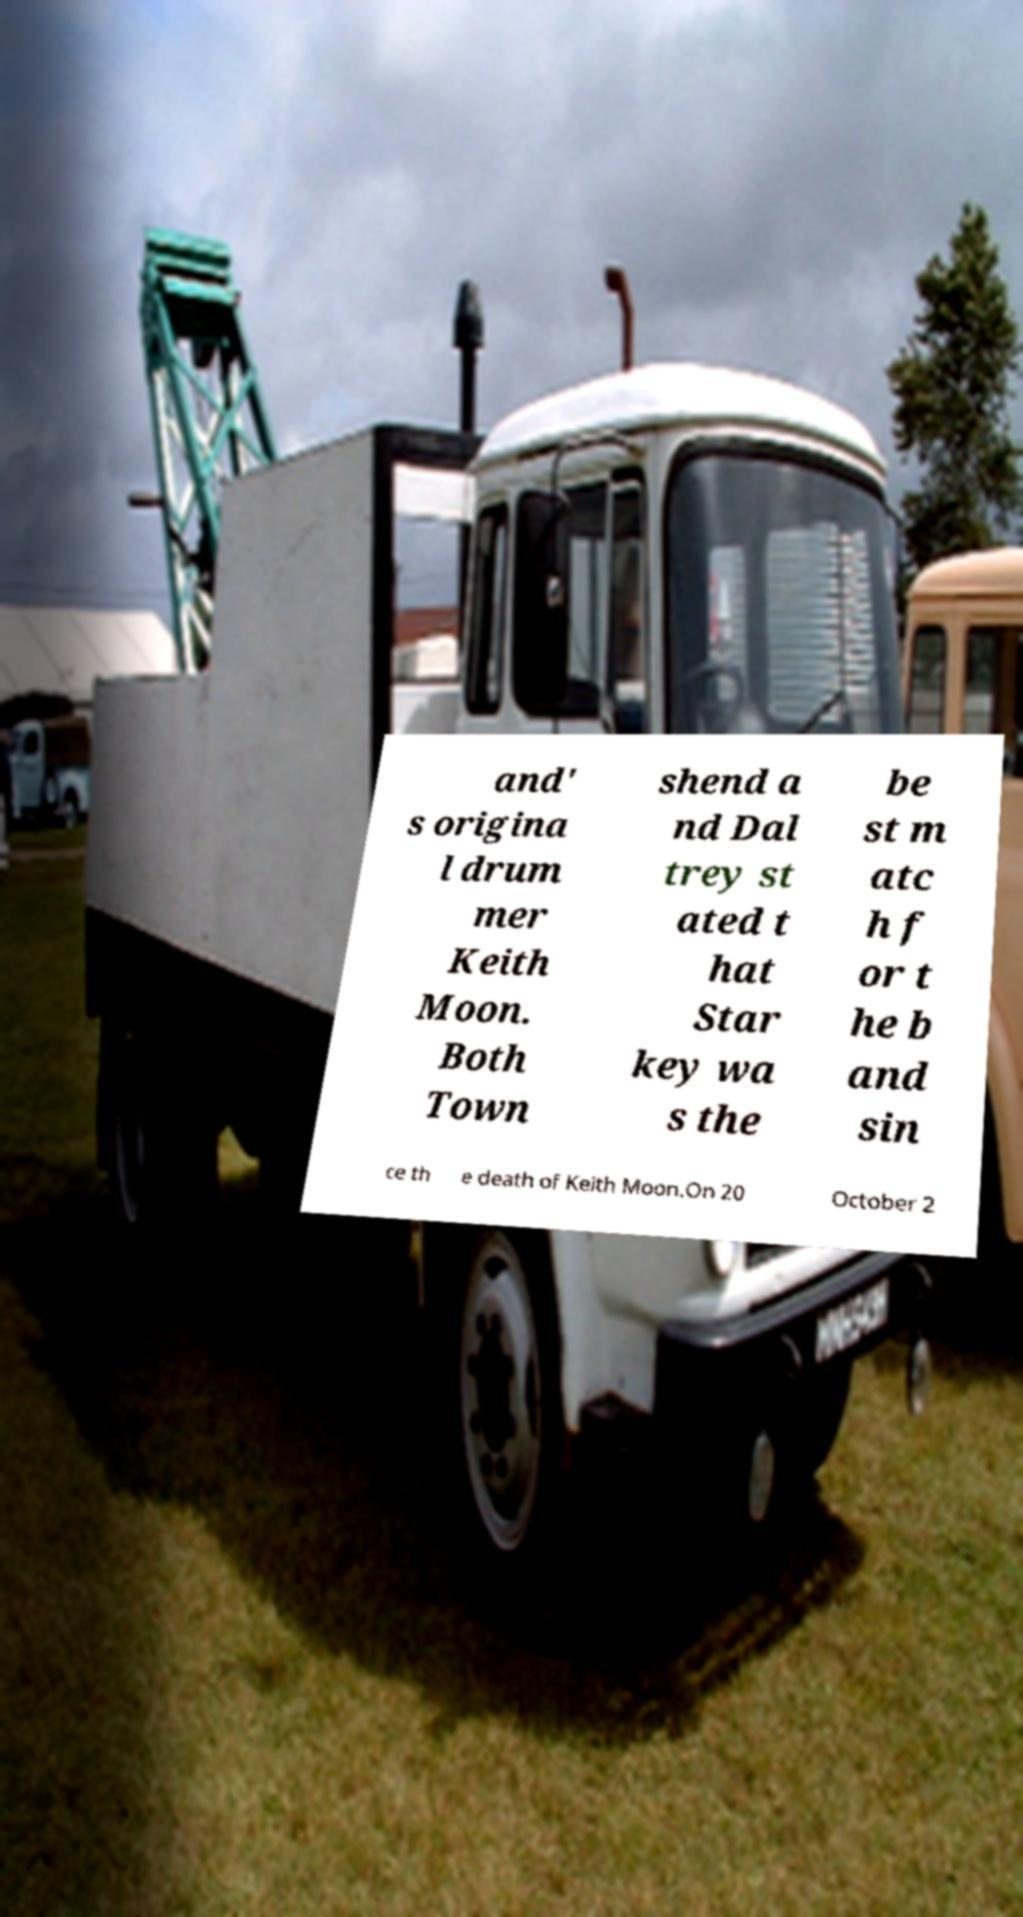I need the written content from this picture converted into text. Can you do that? and' s origina l drum mer Keith Moon. Both Town shend a nd Dal trey st ated t hat Star key wa s the be st m atc h f or t he b and sin ce th e death of Keith Moon.On 20 October 2 